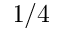Convert formula to latex. <formula><loc_0><loc_0><loc_500><loc_500>1 / 4</formula> 